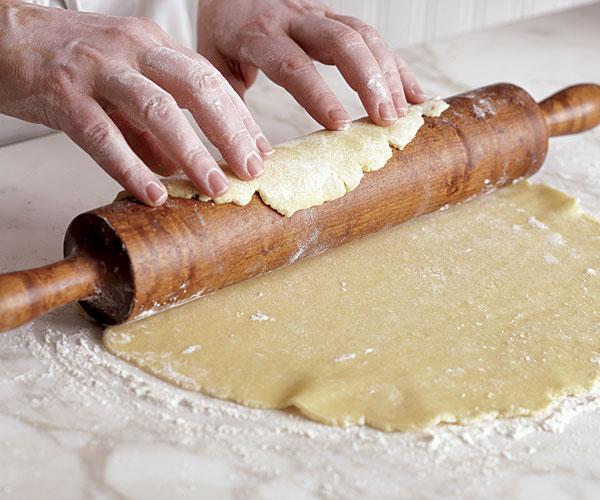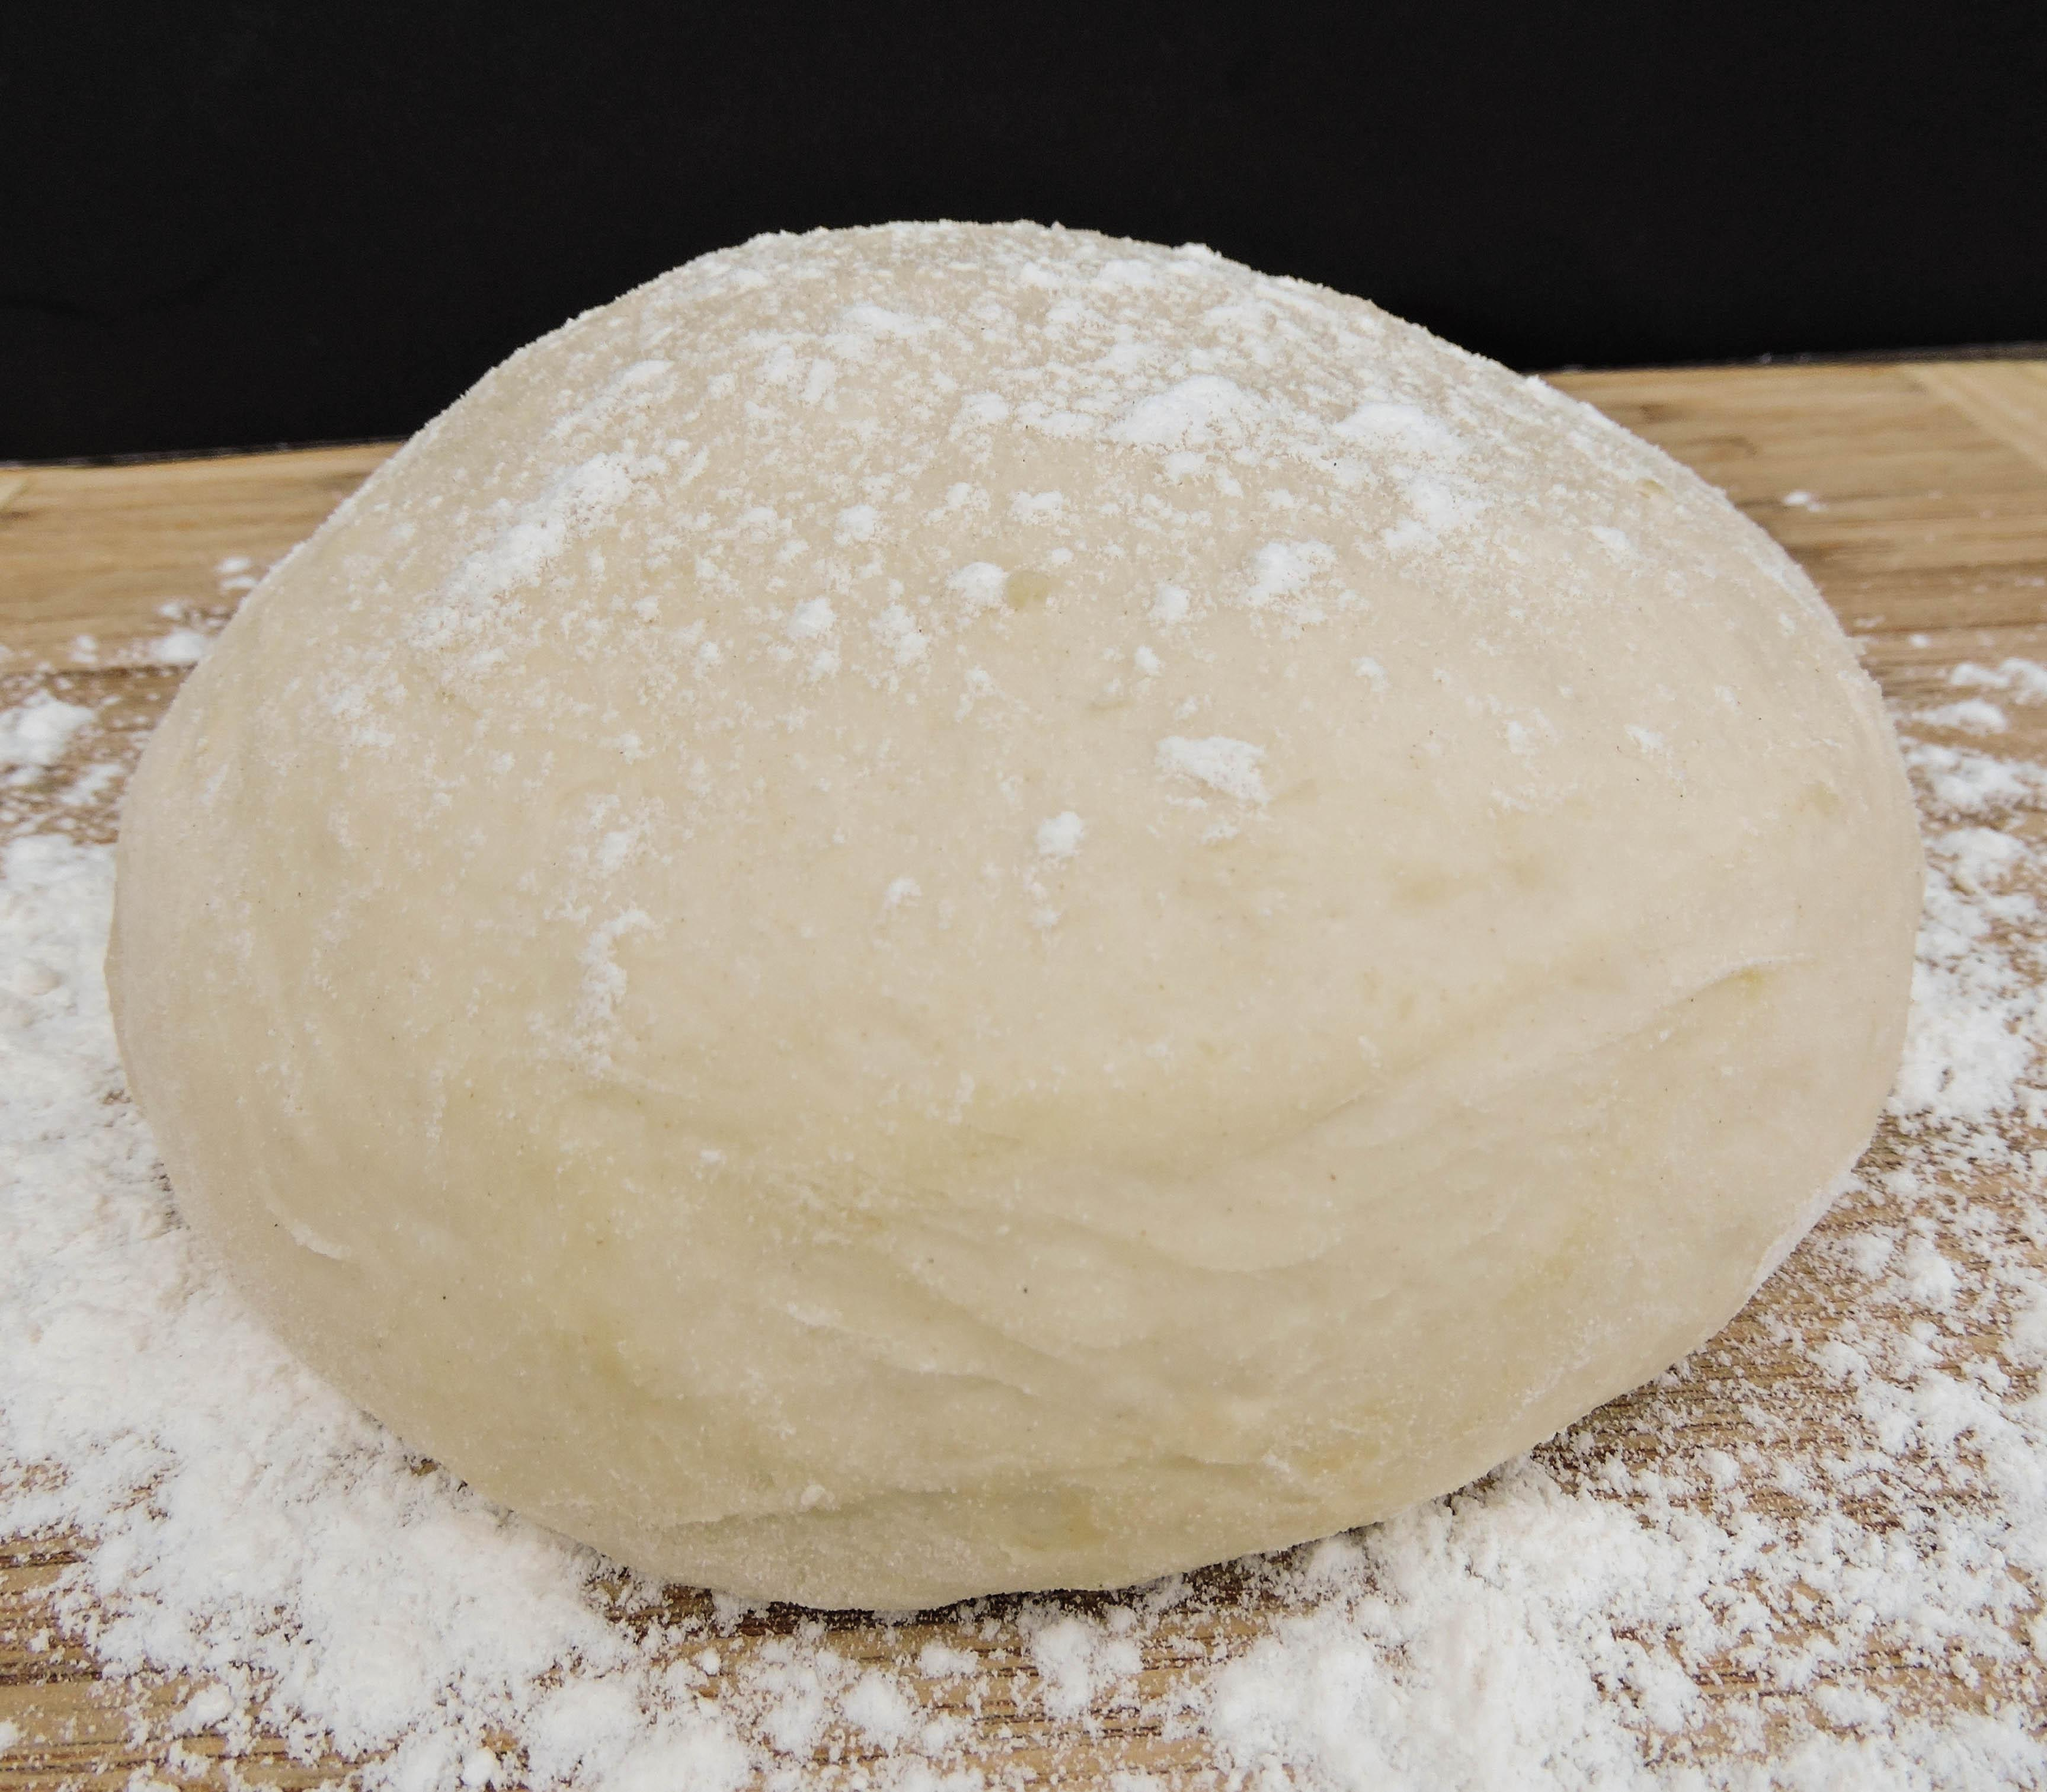The first image is the image on the left, the second image is the image on the right. Evaluate the accuracy of this statement regarding the images: "One and only one of the two images has hands in it.". Is it true? Answer yes or no. Yes. 